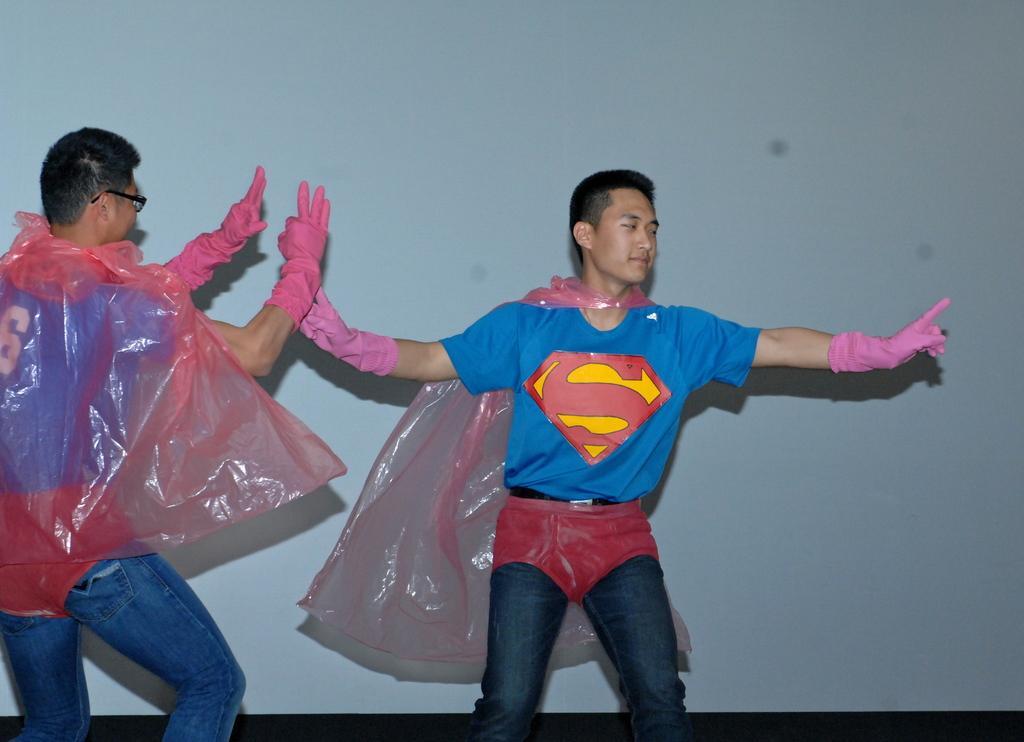Describe this image in one or two sentences. In this picture we can see two men wore gloves and dancing and in the background we can see wall. 